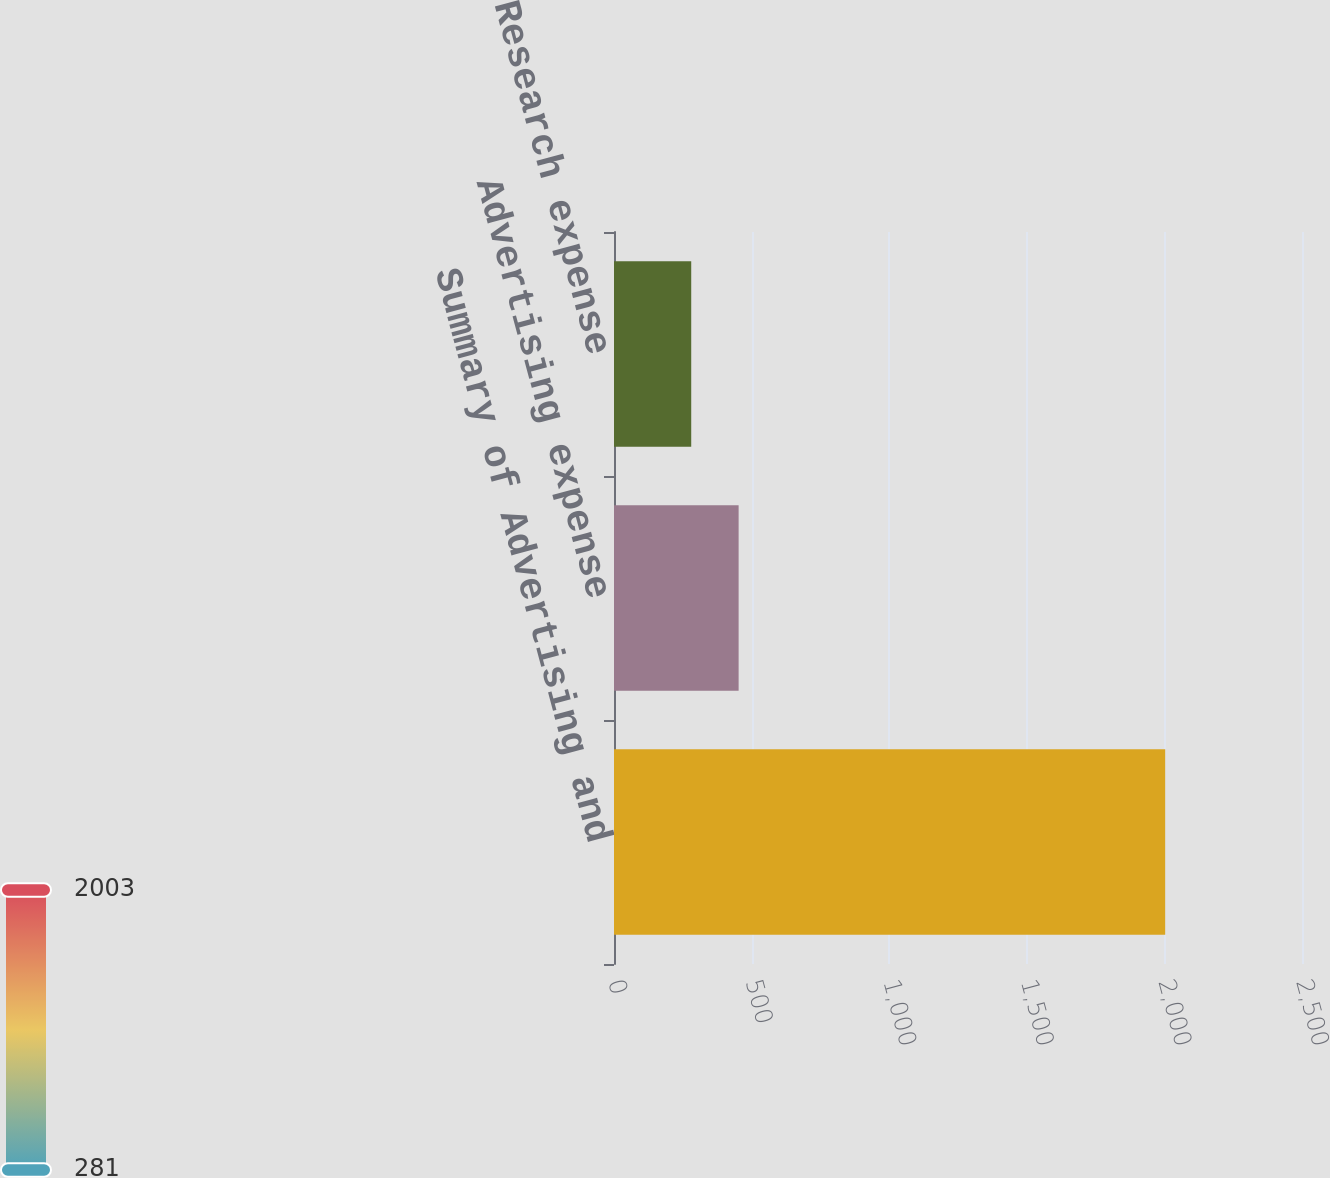Convert chart. <chart><loc_0><loc_0><loc_500><loc_500><bar_chart><fcel>Summary of Advertising and<fcel>Advertising expense<fcel>Research expense<nl><fcel>2003<fcel>452.84<fcel>280.6<nl></chart> 